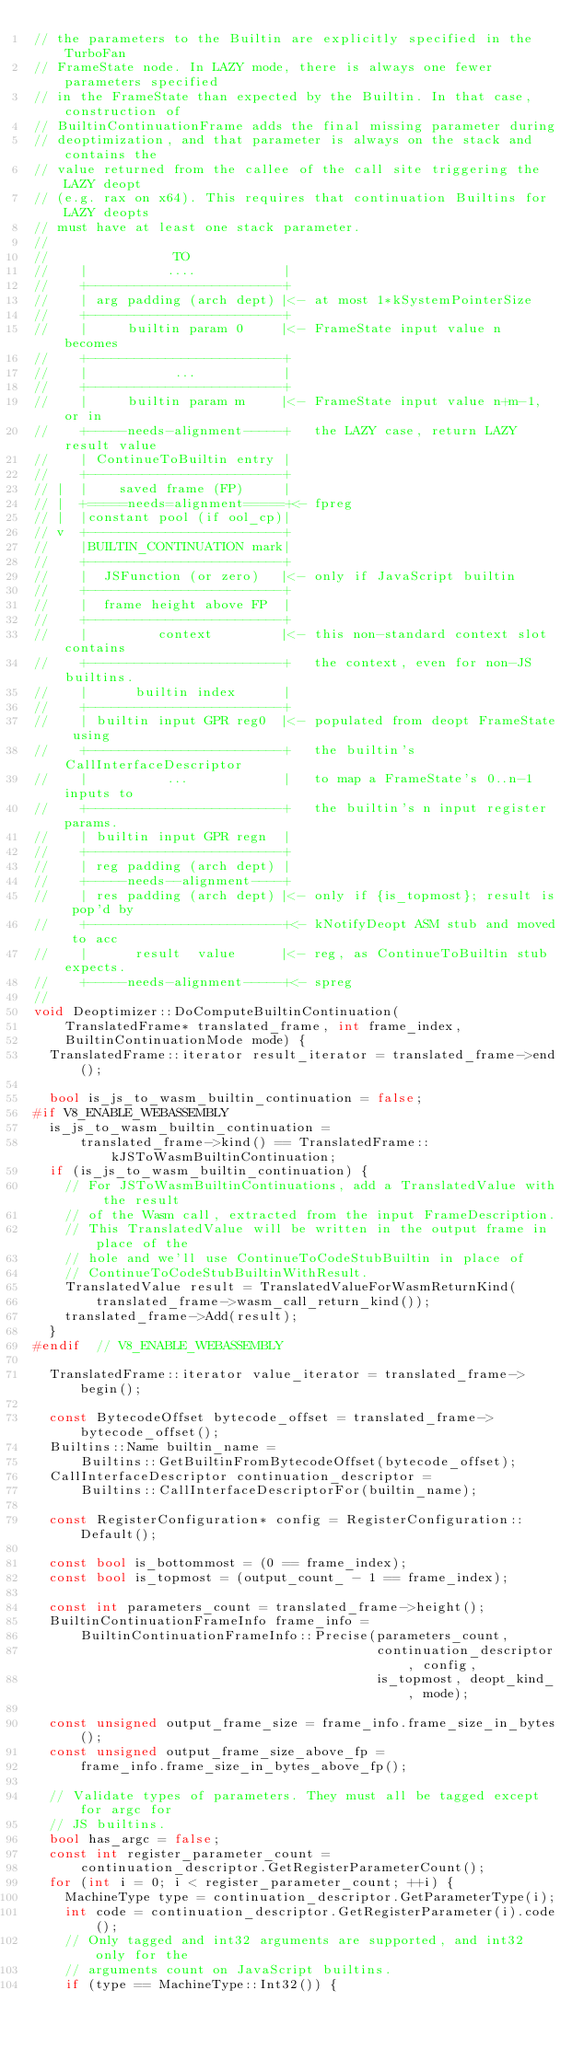Convert code to text. <code><loc_0><loc_0><loc_500><loc_500><_C++_>// the parameters to the Builtin are explicitly specified in the TurboFan
// FrameState node. In LAZY mode, there is always one fewer parameters specified
// in the FrameState than expected by the Builtin. In that case, construction of
// BuiltinContinuationFrame adds the final missing parameter during
// deoptimization, and that parameter is always on the stack and contains the
// value returned from the callee of the call site triggering the LAZY deopt
// (e.g. rax on x64). This requires that continuation Builtins for LAZY deopts
// must have at least one stack parameter.
//
//                TO
//    |          ....           |
//    +-------------------------+
//    | arg padding (arch dept) |<- at most 1*kSystemPointerSize
//    +-------------------------+
//    |     builtin param 0     |<- FrameState input value n becomes
//    +-------------------------+
//    |           ...           |
//    +-------------------------+
//    |     builtin param m     |<- FrameState input value n+m-1, or in
//    +-----needs-alignment-----+   the LAZY case, return LAZY result value
//    | ContinueToBuiltin entry |
//    +-------------------------+
// |  |    saved frame (FP)     |
// |  +=====needs=alignment=====+<- fpreg
// |  |constant pool (if ool_cp)|
// v  +-------------------------+
//    |BUILTIN_CONTINUATION mark|
//    +-------------------------+
//    |  JSFunction (or zero)   |<- only if JavaScript builtin
//    +-------------------------+
//    |  frame height above FP  |
//    +-------------------------+
//    |         context         |<- this non-standard context slot contains
//    +-------------------------+   the context, even for non-JS builtins.
//    |      builtin index      |
//    +-------------------------+
//    | builtin input GPR reg0  |<- populated from deopt FrameState using
//    +-------------------------+   the builtin's CallInterfaceDescriptor
//    |          ...            |   to map a FrameState's 0..n-1 inputs to
//    +-------------------------+   the builtin's n input register params.
//    | builtin input GPR regn  |
//    +-------------------------+
//    | reg padding (arch dept) |
//    +-----needs--alignment----+
//    | res padding (arch dept) |<- only if {is_topmost}; result is pop'd by
//    +-------------------------+<- kNotifyDeopt ASM stub and moved to acc
//    |      result  value      |<- reg, as ContinueToBuiltin stub expects.
//    +-----needs-alignment-----+<- spreg
//
void Deoptimizer::DoComputeBuiltinContinuation(
    TranslatedFrame* translated_frame, int frame_index,
    BuiltinContinuationMode mode) {
  TranslatedFrame::iterator result_iterator = translated_frame->end();

  bool is_js_to_wasm_builtin_continuation = false;
#if V8_ENABLE_WEBASSEMBLY
  is_js_to_wasm_builtin_continuation =
      translated_frame->kind() == TranslatedFrame::kJSToWasmBuiltinContinuation;
  if (is_js_to_wasm_builtin_continuation) {
    // For JSToWasmBuiltinContinuations, add a TranslatedValue with the result
    // of the Wasm call, extracted from the input FrameDescription.
    // This TranslatedValue will be written in the output frame in place of the
    // hole and we'll use ContinueToCodeStubBuiltin in place of
    // ContinueToCodeStubBuiltinWithResult.
    TranslatedValue result = TranslatedValueForWasmReturnKind(
        translated_frame->wasm_call_return_kind());
    translated_frame->Add(result);
  }
#endif  // V8_ENABLE_WEBASSEMBLY

  TranslatedFrame::iterator value_iterator = translated_frame->begin();

  const BytecodeOffset bytecode_offset = translated_frame->bytecode_offset();
  Builtins::Name builtin_name =
      Builtins::GetBuiltinFromBytecodeOffset(bytecode_offset);
  CallInterfaceDescriptor continuation_descriptor =
      Builtins::CallInterfaceDescriptorFor(builtin_name);

  const RegisterConfiguration* config = RegisterConfiguration::Default();

  const bool is_bottommost = (0 == frame_index);
  const bool is_topmost = (output_count_ - 1 == frame_index);

  const int parameters_count = translated_frame->height();
  BuiltinContinuationFrameInfo frame_info =
      BuiltinContinuationFrameInfo::Precise(parameters_count,
                                            continuation_descriptor, config,
                                            is_topmost, deopt_kind_, mode);

  const unsigned output_frame_size = frame_info.frame_size_in_bytes();
  const unsigned output_frame_size_above_fp =
      frame_info.frame_size_in_bytes_above_fp();

  // Validate types of parameters. They must all be tagged except for argc for
  // JS builtins.
  bool has_argc = false;
  const int register_parameter_count =
      continuation_descriptor.GetRegisterParameterCount();
  for (int i = 0; i < register_parameter_count; ++i) {
    MachineType type = continuation_descriptor.GetParameterType(i);
    int code = continuation_descriptor.GetRegisterParameter(i).code();
    // Only tagged and int32 arguments are supported, and int32 only for the
    // arguments count on JavaScript builtins.
    if (type == MachineType::Int32()) {</code> 